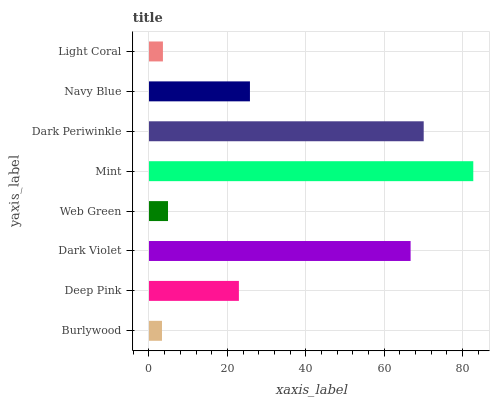Is Burlywood the minimum?
Answer yes or no. Yes. Is Mint the maximum?
Answer yes or no. Yes. Is Deep Pink the minimum?
Answer yes or no. No. Is Deep Pink the maximum?
Answer yes or no. No. Is Deep Pink greater than Burlywood?
Answer yes or no. Yes. Is Burlywood less than Deep Pink?
Answer yes or no. Yes. Is Burlywood greater than Deep Pink?
Answer yes or no. No. Is Deep Pink less than Burlywood?
Answer yes or no. No. Is Navy Blue the high median?
Answer yes or no. Yes. Is Deep Pink the low median?
Answer yes or no. Yes. Is Burlywood the high median?
Answer yes or no. No. Is Dark Periwinkle the low median?
Answer yes or no. No. 